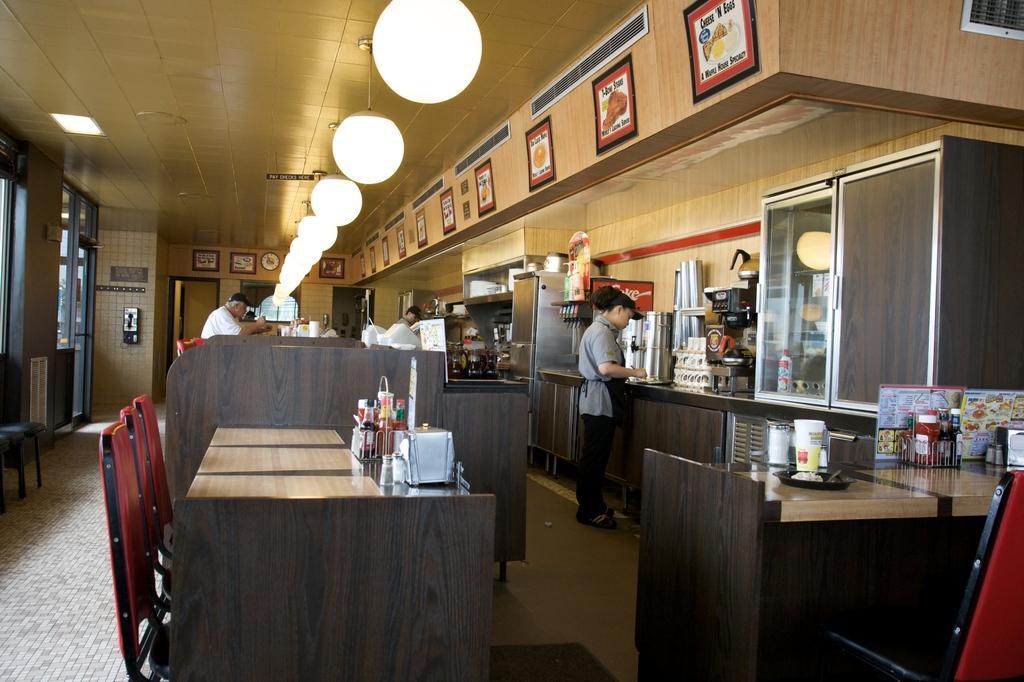Describe this image in one or two sentences. At the top we can see ceiling and lights. We can see boards here at the top. We can see persons standing here on the floor. These are chairs and tables and on the table we can see bottles, plates. This is a platform and on the platform we can see cupboard, machine. This is a floor. 